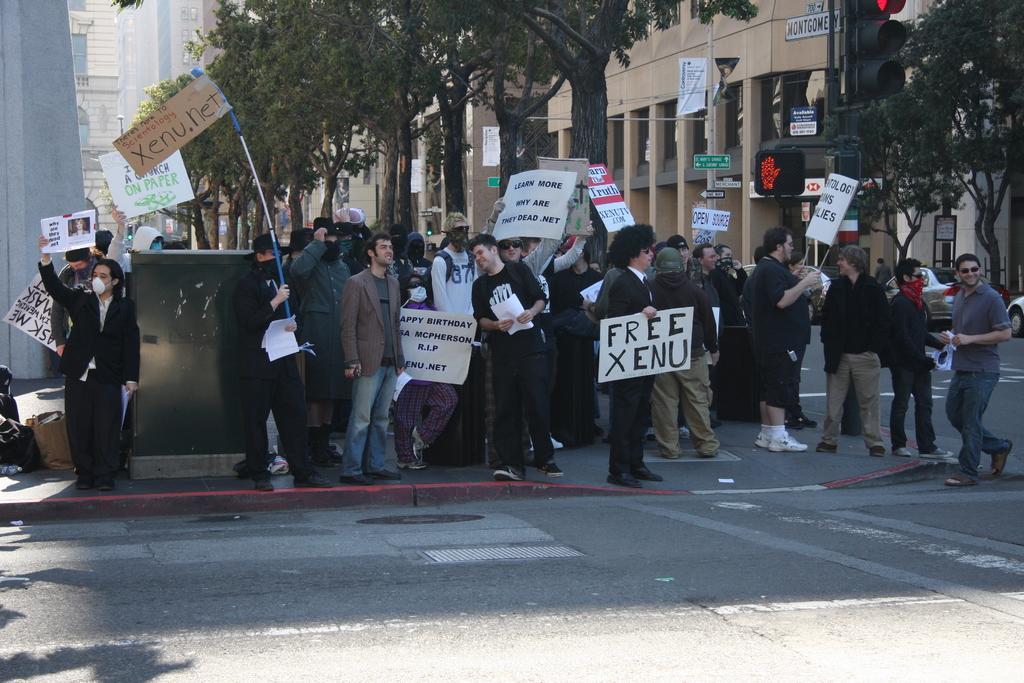Can you describe this image briefly? In this picture I can see there are few people standing and they are holding boards and wearing masks. In the backdrop I can see there are buildings. 